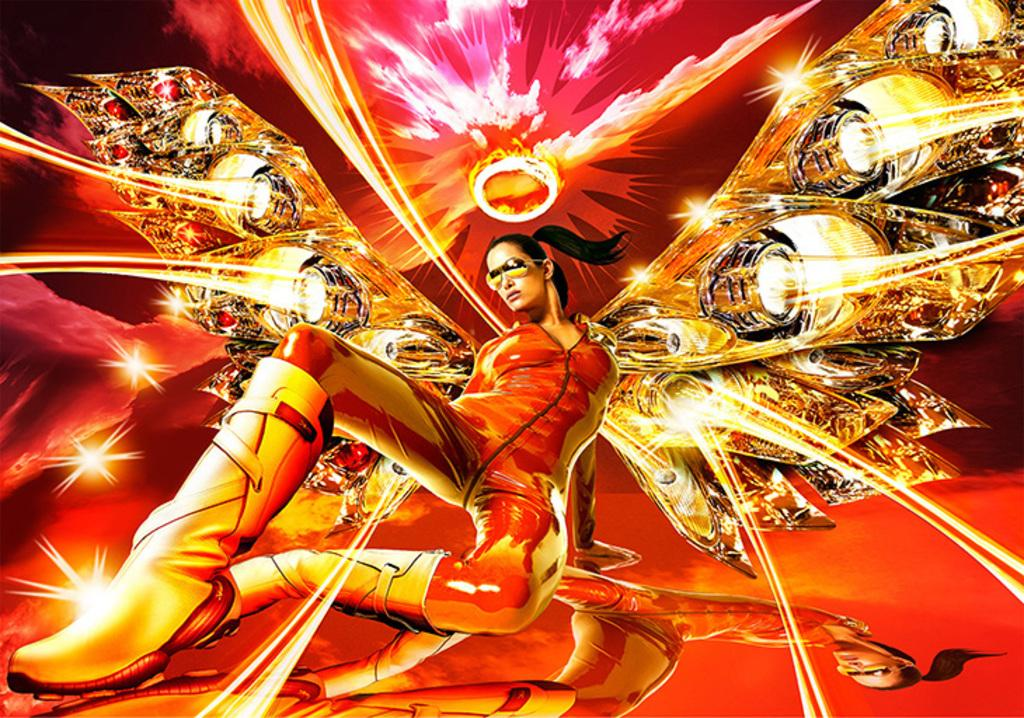What type of media is the image? The image is an animation. Can you describe the character in the animation? There is a woman in the image. What type of glass is the woman holding in the image? There is no glass present in the image; it is an animation featuring a woman. 